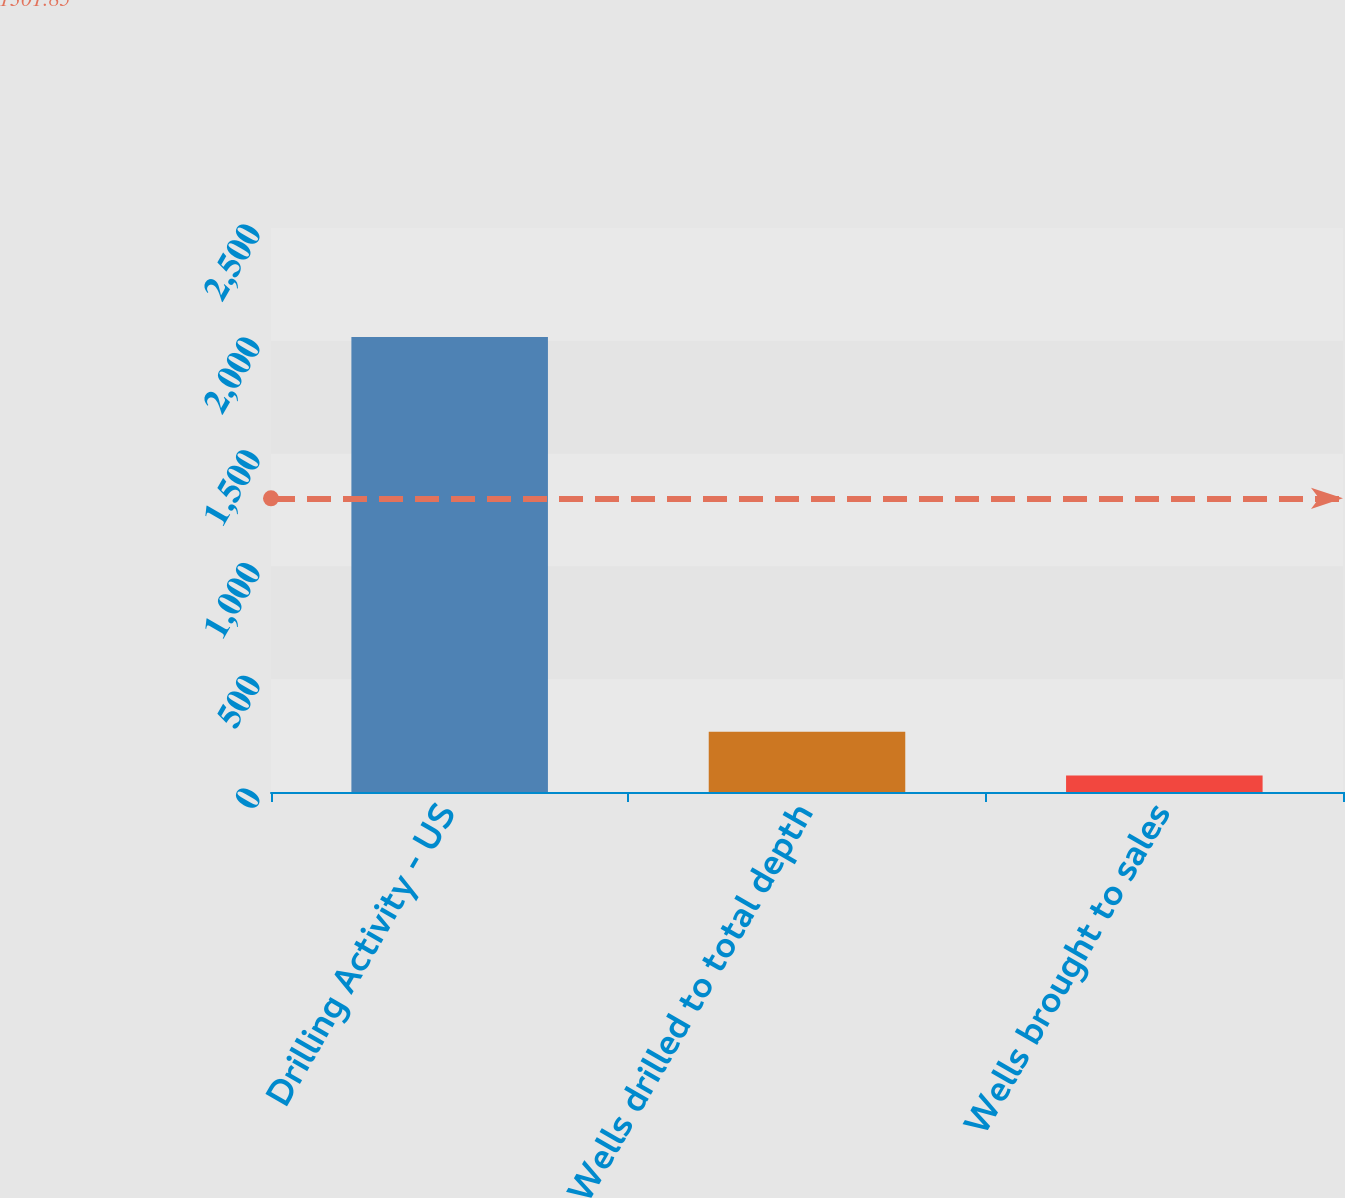Convert chart. <chart><loc_0><loc_0><loc_500><loc_500><bar_chart><fcel>Drilling Activity - US<fcel>Wells drilled to total depth<fcel>Wells brought to sales<nl><fcel>2017<fcel>267.4<fcel>73<nl></chart> 